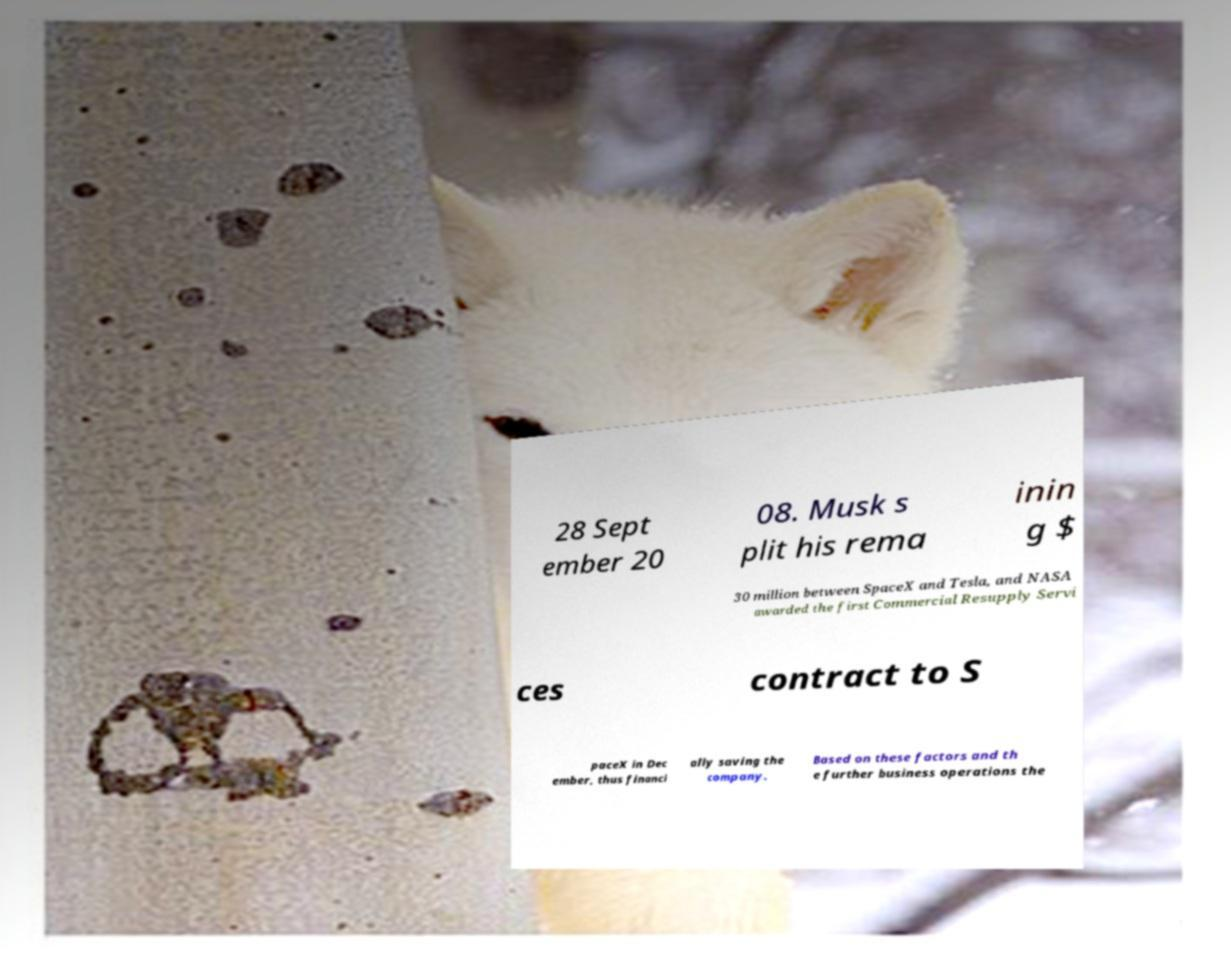What messages or text are displayed in this image? I need them in a readable, typed format. 28 Sept ember 20 08. Musk s plit his rema inin g $ 30 million between SpaceX and Tesla, and NASA awarded the first Commercial Resupply Servi ces contract to S paceX in Dec ember, thus financi ally saving the company. Based on these factors and th e further business operations the 